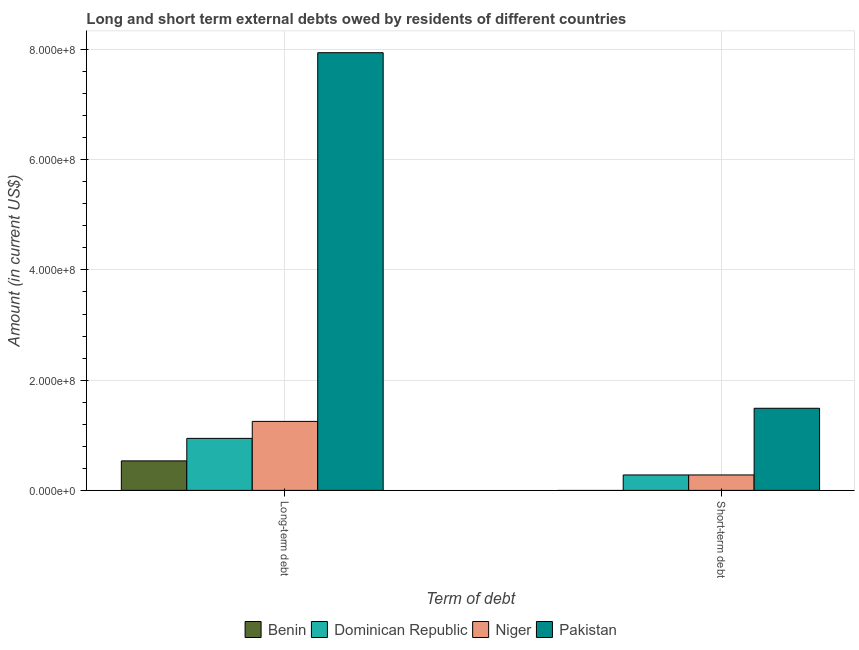How many different coloured bars are there?
Make the answer very short. 4. Are the number of bars per tick equal to the number of legend labels?
Offer a very short reply. No. How many bars are there on the 1st tick from the left?
Your answer should be compact. 4. What is the label of the 2nd group of bars from the left?
Provide a succinct answer. Short-term debt. What is the long-term debts owed by residents in Niger?
Offer a terse response. 1.25e+08. Across all countries, what is the maximum short-term debts owed by residents?
Ensure brevity in your answer.  1.49e+08. Across all countries, what is the minimum long-term debts owed by residents?
Your response must be concise. 5.35e+07. What is the total short-term debts owed by residents in the graph?
Give a very brief answer. 2.05e+08. What is the difference between the long-term debts owed by residents in Pakistan and that in Benin?
Your answer should be very brief. 7.41e+08. What is the difference between the short-term debts owed by residents in Niger and the long-term debts owed by residents in Dominican Republic?
Keep it short and to the point. -6.64e+07. What is the average short-term debts owed by residents per country?
Provide a short and direct response. 5.12e+07. What is the difference between the long-term debts owed by residents and short-term debts owed by residents in Niger?
Your answer should be very brief. 9.72e+07. Is the short-term debts owed by residents in Niger less than that in Dominican Republic?
Your answer should be compact. No. How many countries are there in the graph?
Offer a terse response. 4. Are the values on the major ticks of Y-axis written in scientific E-notation?
Make the answer very short. Yes. Does the graph contain grids?
Provide a succinct answer. Yes. Where does the legend appear in the graph?
Give a very brief answer. Bottom center. What is the title of the graph?
Keep it short and to the point. Long and short term external debts owed by residents of different countries. Does "Brunei Darussalam" appear as one of the legend labels in the graph?
Your response must be concise. No. What is the label or title of the X-axis?
Ensure brevity in your answer.  Term of debt. What is the Amount (in current US$) in Benin in Long-term debt?
Provide a succinct answer. 5.35e+07. What is the Amount (in current US$) of Dominican Republic in Long-term debt?
Your answer should be very brief. 9.44e+07. What is the Amount (in current US$) of Niger in Long-term debt?
Make the answer very short. 1.25e+08. What is the Amount (in current US$) in Pakistan in Long-term debt?
Your answer should be compact. 7.94e+08. What is the Amount (in current US$) in Dominican Republic in Short-term debt?
Your response must be concise. 2.80e+07. What is the Amount (in current US$) in Niger in Short-term debt?
Make the answer very short. 2.80e+07. What is the Amount (in current US$) in Pakistan in Short-term debt?
Ensure brevity in your answer.  1.49e+08. Across all Term of debt, what is the maximum Amount (in current US$) of Benin?
Offer a terse response. 5.35e+07. Across all Term of debt, what is the maximum Amount (in current US$) of Dominican Republic?
Your answer should be compact. 9.44e+07. Across all Term of debt, what is the maximum Amount (in current US$) in Niger?
Your answer should be compact. 1.25e+08. Across all Term of debt, what is the maximum Amount (in current US$) of Pakistan?
Make the answer very short. 7.94e+08. Across all Term of debt, what is the minimum Amount (in current US$) in Benin?
Ensure brevity in your answer.  0. Across all Term of debt, what is the minimum Amount (in current US$) of Dominican Republic?
Offer a very short reply. 2.80e+07. Across all Term of debt, what is the minimum Amount (in current US$) of Niger?
Give a very brief answer. 2.80e+07. Across all Term of debt, what is the minimum Amount (in current US$) of Pakistan?
Your answer should be compact. 1.49e+08. What is the total Amount (in current US$) of Benin in the graph?
Your answer should be very brief. 5.35e+07. What is the total Amount (in current US$) of Dominican Republic in the graph?
Offer a very short reply. 1.22e+08. What is the total Amount (in current US$) in Niger in the graph?
Keep it short and to the point. 1.53e+08. What is the total Amount (in current US$) in Pakistan in the graph?
Keep it short and to the point. 9.43e+08. What is the difference between the Amount (in current US$) of Dominican Republic in Long-term debt and that in Short-term debt?
Your answer should be very brief. 6.64e+07. What is the difference between the Amount (in current US$) in Niger in Long-term debt and that in Short-term debt?
Your answer should be very brief. 9.72e+07. What is the difference between the Amount (in current US$) in Pakistan in Long-term debt and that in Short-term debt?
Your answer should be very brief. 6.45e+08. What is the difference between the Amount (in current US$) of Benin in Long-term debt and the Amount (in current US$) of Dominican Republic in Short-term debt?
Make the answer very short. 2.55e+07. What is the difference between the Amount (in current US$) of Benin in Long-term debt and the Amount (in current US$) of Niger in Short-term debt?
Ensure brevity in your answer.  2.55e+07. What is the difference between the Amount (in current US$) in Benin in Long-term debt and the Amount (in current US$) in Pakistan in Short-term debt?
Make the answer very short. -9.55e+07. What is the difference between the Amount (in current US$) of Dominican Republic in Long-term debt and the Amount (in current US$) of Niger in Short-term debt?
Your response must be concise. 6.64e+07. What is the difference between the Amount (in current US$) in Dominican Republic in Long-term debt and the Amount (in current US$) in Pakistan in Short-term debt?
Offer a very short reply. -5.46e+07. What is the difference between the Amount (in current US$) of Niger in Long-term debt and the Amount (in current US$) of Pakistan in Short-term debt?
Make the answer very short. -2.38e+07. What is the average Amount (in current US$) of Benin per Term of debt?
Your response must be concise. 2.68e+07. What is the average Amount (in current US$) in Dominican Republic per Term of debt?
Keep it short and to the point. 6.12e+07. What is the average Amount (in current US$) of Niger per Term of debt?
Make the answer very short. 7.66e+07. What is the average Amount (in current US$) in Pakistan per Term of debt?
Ensure brevity in your answer.  4.72e+08. What is the difference between the Amount (in current US$) in Benin and Amount (in current US$) in Dominican Republic in Long-term debt?
Keep it short and to the point. -4.08e+07. What is the difference between the Amount (in current US$) of Benin and Amount (in current US$) of Niger in Long-term debt?
Keep it short and to the point. -7.16e+07. What is the difference between the Amount (in current US$) of Benin and Amount (in current US$) of Pakistan in Long-term debt?
Keep it short and to the point. -7.41e+08. What is the difference between the Amount (in current US$) of Dominican Republic and Amount (in current US$) of Niger in Long-term debt?
Offer a very short reply. -3.08e+07. What is the difference between the Amount (in current US$) in Dominican Republic and Amount (in current US$) in Pakistan in Long-term debt?
Ensure brevity in your answer.  -7.00e+08. What is the difference between the Amount (in current US$) of Niger and Amount (in current US$) of Pakistan in Long-term debt?
Offer a terse response. -6.69e+08. What is the difference between the Amount (in current US$) in Dominican Republic and Amount (in current US$) in Pakistan in Short-term debt?
Provide a succinct answer. -1.21e+08. What is the difference between the Amount (in current US$) of Niger and Amount (in current US$) of Pakistan in Short-term debt?
Offer a terse response. -1.21e+08. What is the ratio of the Amount (in current US$) in Dominican Republic in Long-term debt to that in Short-term debt?
Provide a succinct answer. 3.37. What is the ratio of the Amount (in current US$) in Niger in Long-term debt to that in Short-term debt?
Keep it short and to the point. 4.47. What is the ratio of the Amount (in current US$) of Pakistan in Long-term debt to that in Short-term debt?
Make the answer very short. 5.33. What is the difference between the highest and the second highest Amount (in current US$) of Dominican Republic?
Keep it short and to the point. 6.64e+07. What is the difference between the highest and the second highest Amount (in current US$) in Niger?
Ensure brevity in your answer.  9.72e+07. What is the difference between the highest and the second highest Amount (in current US$) of Pakistan?
Your answer should be very brief. 6.45e+08. What is the difference between the highest and the lowest Amount (in current US$) in Benin?
Your response must be concise. 5.35e+07. What is the difference between the highest and the lowest Amount (in current US$) in Dominican Republic?
Offer a very short reply. 6.64e+07. What is the difference between the highest and the lowest Amount (in current US$) of Niger?
Your answer should be compact. 9.72e+07. What is the difference between the highest and the lowest Amount (in current US$) of Pakistan?
Make the answer very short. 6.45e+08. 